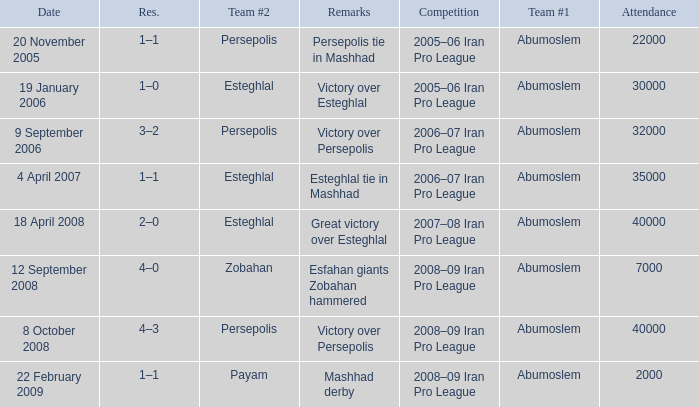Would you be able to parse every entry in this table? {'header': ['Date', 'Res.', 'Team #2', 'Remarks', 'Competition', 'Team #1', 'Attendance'], 'rows': [['20 November 2005', '1–1', 'Persepolis', 'Persepolis tie in Mashhad', '2005–06 Iran Pro League', 'Abumoslem', '22000'], ['19 January 2006', '1–0', 'Esteghlal', 'Victory over Esteghlal', '2005–06 Iran Pro League', 'Abumoslem', '30000'], ['9 September 2006', '3–2', 'Persepolis', 'Victory over Persepolis', '2006–07 Iran Pro League', 'Abumoslem', '32000'], ['4 April 2007', '1–1', 'Esteghlal', 'Esteghlal tie in Mashhad', '2006–07 Iran Pro League', 'Abumoslem', '35000'], ['18 April 2008', '2–0', 'Esteghlal', 'Great victory over Esteghlal', '2007–08 Iran Pro League', 'Abumoslem', '40000'], ['12 September 2008', '4–0', 'Zobahan', 'Esfahan giants Zobahan hammered', '2008–09 Iran Pro League', 'Abumoslem', '7000'], ['8 October 2008', '4–3', 'Persepolis', 'Victory over Persepolis', '2008–09 Iran Pro League', 'Abumoslem', '40000'], ['22 February 2009', '1–1', 'Payam', 'Mashhad derby', '2008–09 Iran Pro League', 'Abumoslem', '2000']]} What are the remarks for 8 October 2008? Victory over Persepolis. 